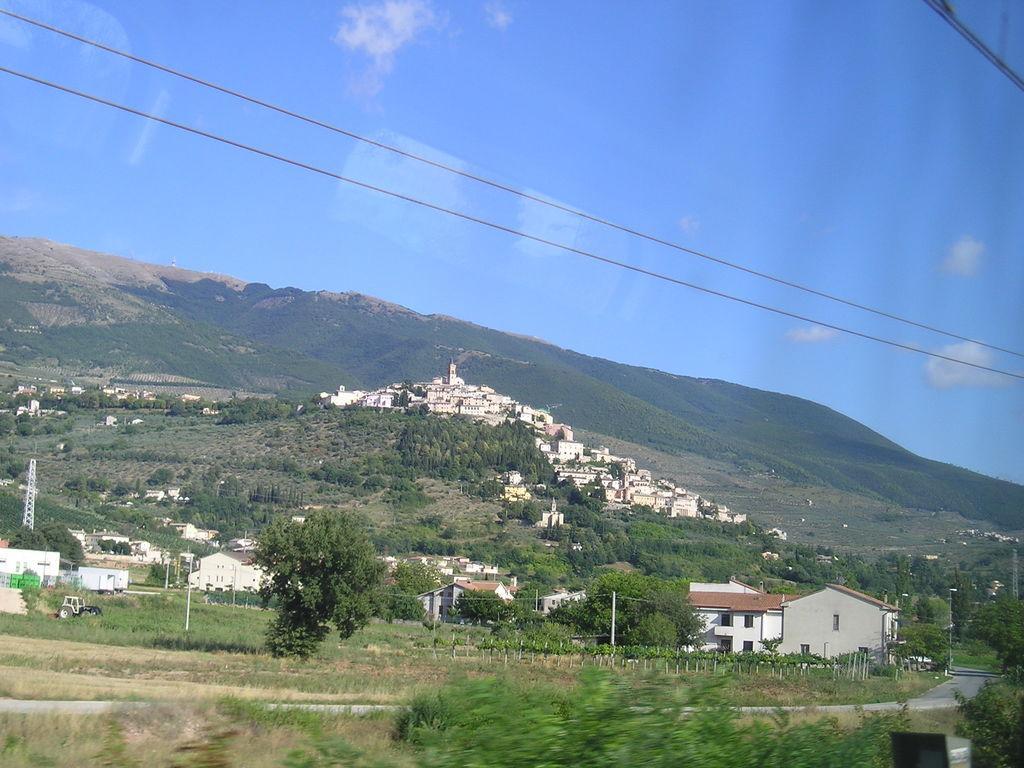Describe this image in one or two sentences. In this picture we can see mountains, trees and houses. Here the sky is blue. 